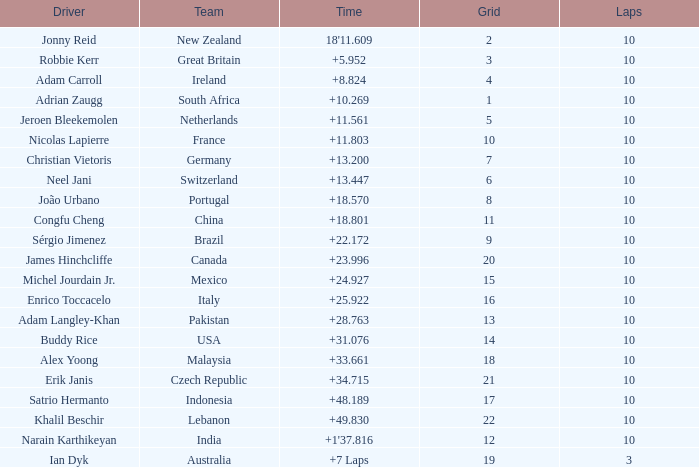For what Team is Narain Karthikeyan the Driver? India. 